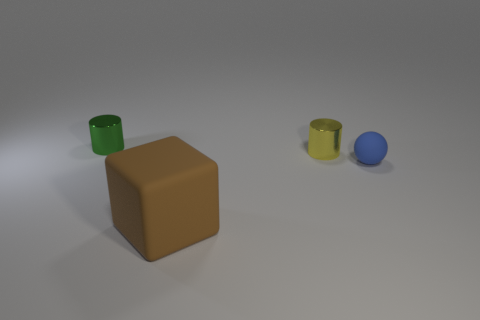There is a cylinder to the right of the rubber cube; does it have the same size as the large rubber block?
Offer a terse response. No. There is a tiny green object; what shape is it?
Your answer should be very brief. Cylinder. How many other blue matte objects have the same shape as the tiny blue thing?
Your answer should be compact. 0. What number of tiny cylinders are in front of the small green shiny object and on the left side of the brown block?
Offer a very short reply. 0. What is the color of the rubber ball?
Your response must be concise. Blue. Are there any small things that have the same material as the large thing?
Offer a very short reply. Yes. Are there any shiny objects that are on the left side of the small shiny object that is in front of the small object on the left side of the big matte cube?
Offer a very short reply. Yes. There is a green metal cylinder; are there any rubber blocks on the right side of it?
Provide a short and direct response. Yes. How many big things are yellow metal things or green cylinders?
Your response must be concise. 0. Is the material of the cylinder in front of the small green shiny cylinder the same as the green cylinder?
Your response must be concise. Yes. 